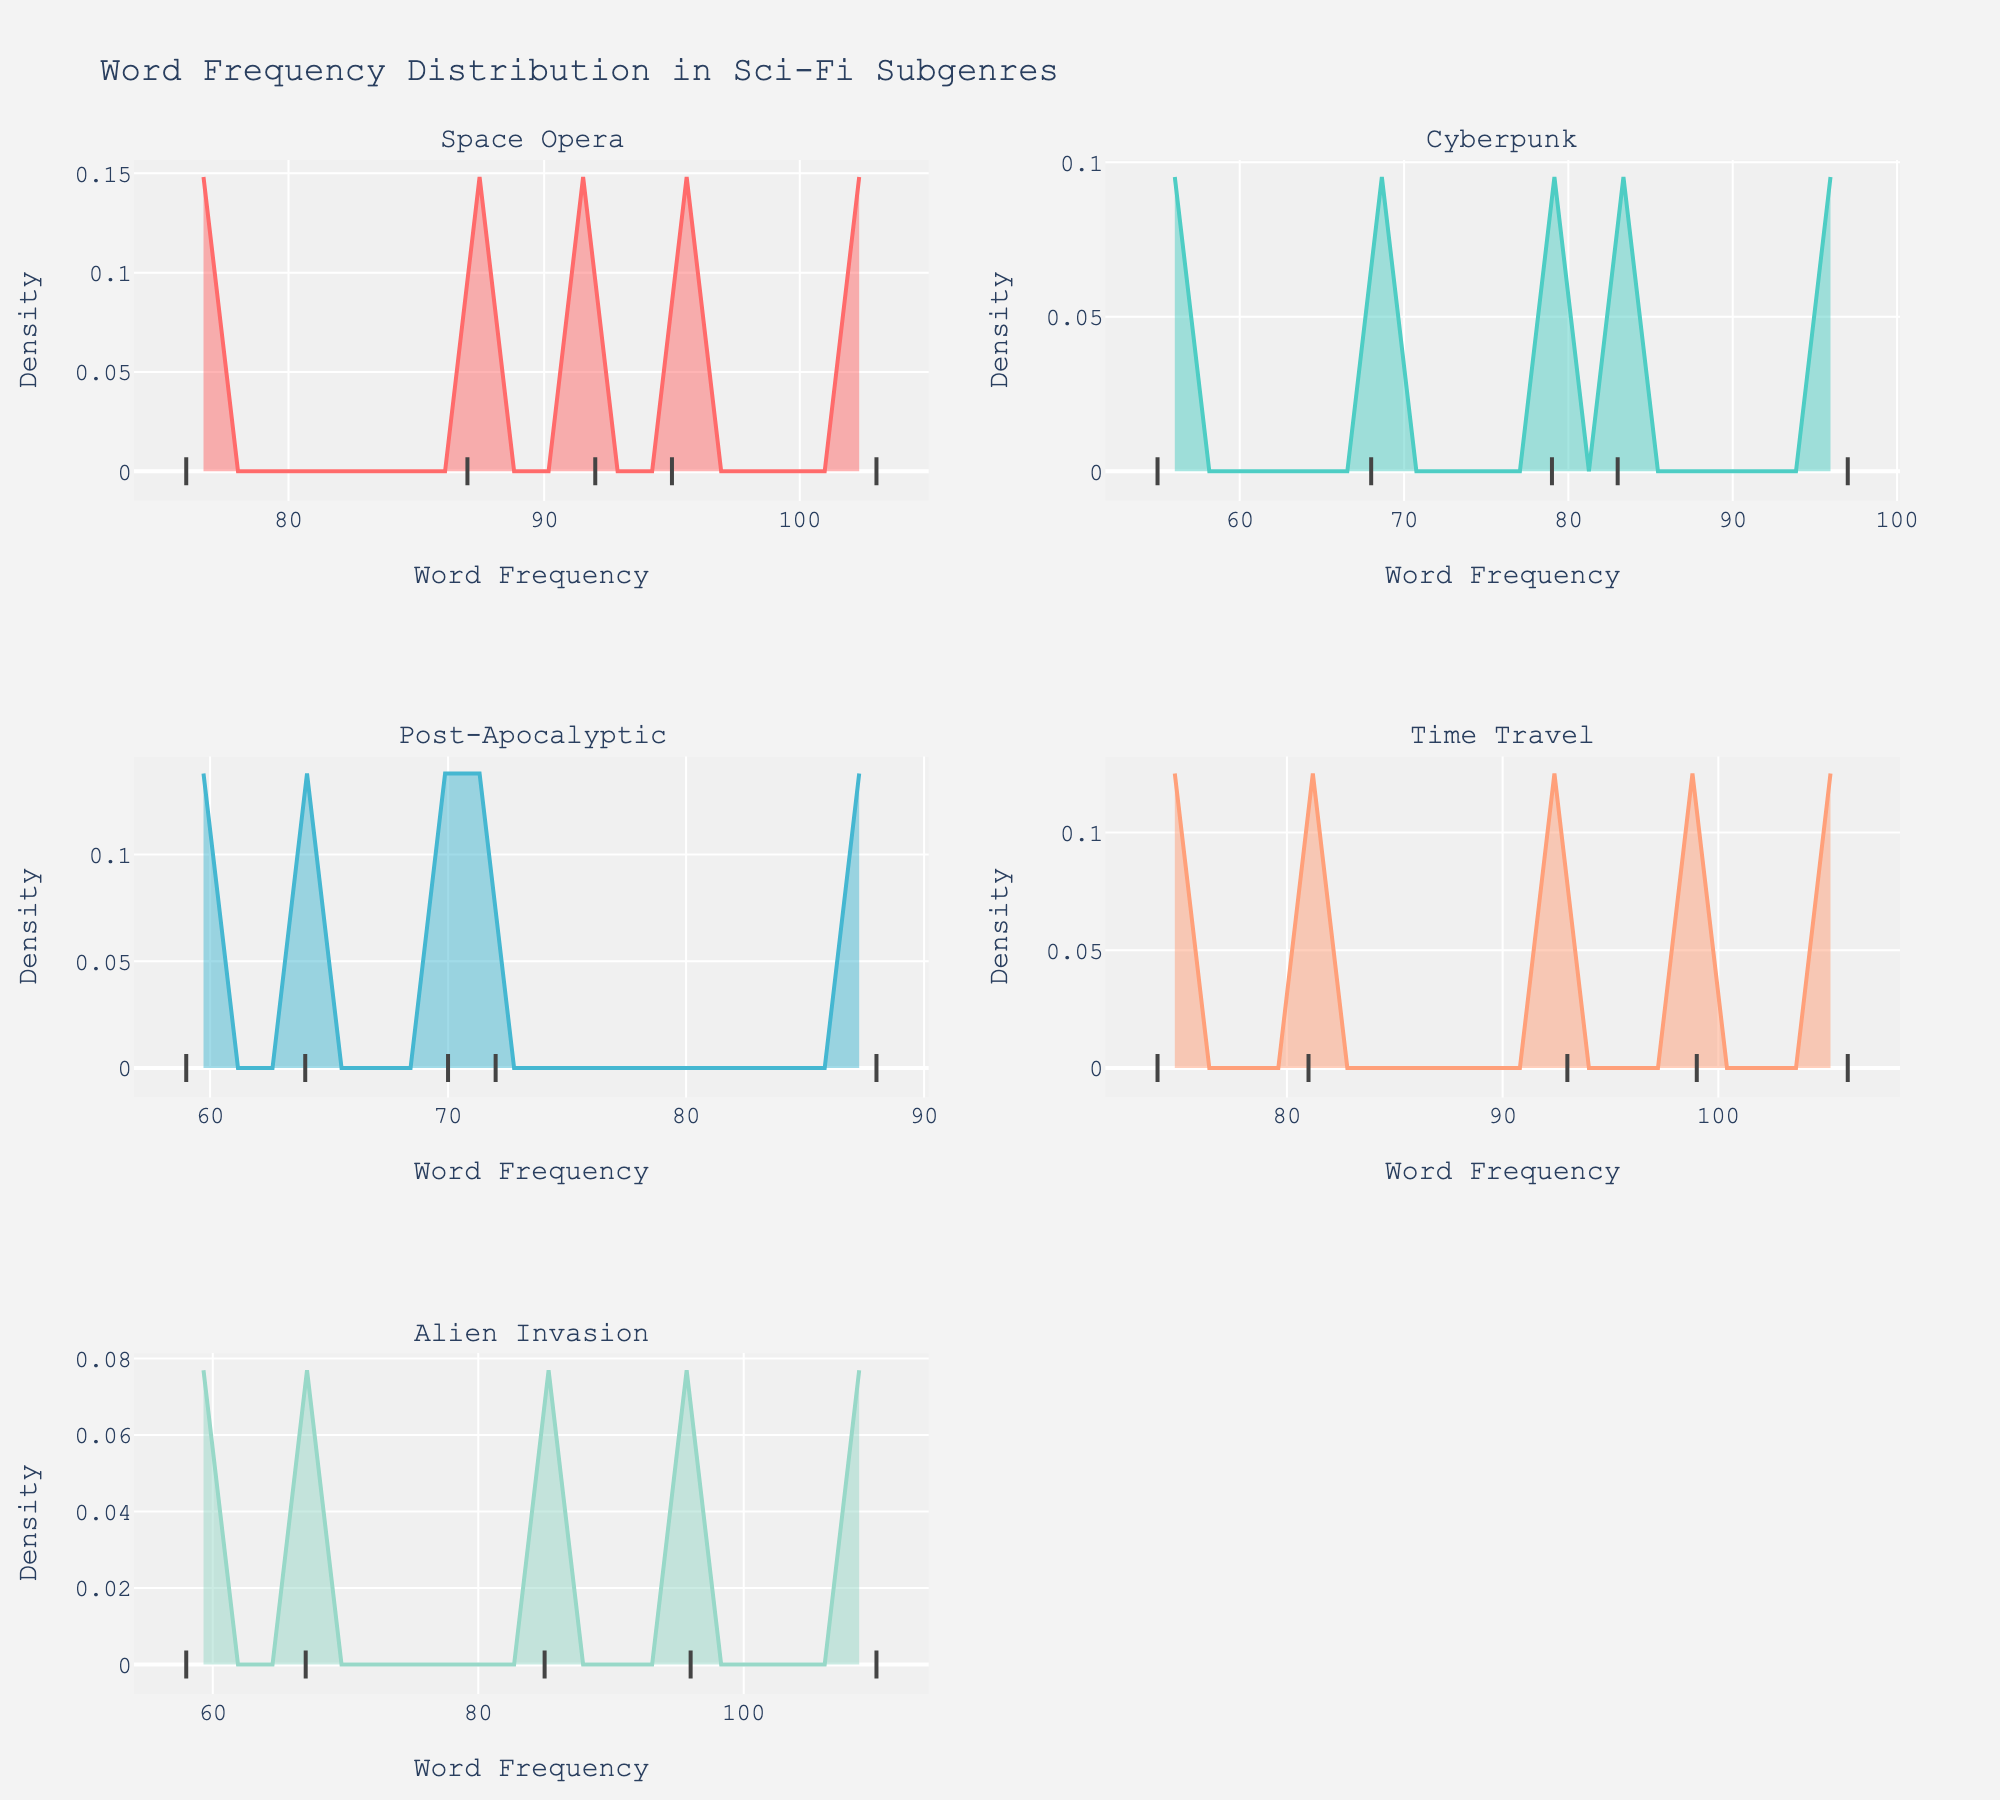Which subgenre has the word with the highest frequency? By looking at the highest peak on the x-axis in each subplot, you can determine the word with the highest frequency. For 'Alien Invasion', the peak reaches around 110 for the word 'invasion', which is the highest among all subgenres.
Answer: Alien Invasion Which subgenre shows the least variability in word frequency? Variability can be inferred from how spread out the points are along the x-axis. 'Cyberpunk' has points that are less spread out compared to other subgenres, suggesting lower variability in word frequencies.
Answer: Cyberpunk How many subgenres exhibit a bimodal distribution? A bimodal distribution is indicated by two distinct peaks in the density plot. By examining each subplot, only 'Time Travel' shows a clear bimodal pattern.
Answer: 1 Which word in the Post-Apocalyptic subgenre has the lowest frequency? In the Post-Apocalyptic subplot, the word 'scavenge' is positioned the furthest to the left on the x-axis, indicating the lowest frequency.
Answer: scavenge What is the frequency of the word 'AI' in the Cyberpunk subgenre? Refer to the specific marker for 'AI' in the Cyberpunk subplot, marked at approximately 97 on the x-axis.
Answer: 97 Is the peak of word frequency density higher in 'Time Travel' or 'Space Opera'? Compare the maximum y-values (height of peaks) of the density plots. The peak in 'Space Opera' is higher than in 'Time Travel'.
Answer: Space Opera What is the average frequency of words in the 'Space Opera' subgenre? Sum the frequencies of the words in 'Space Opera' (87 + 103 + 95 + 76 + 92) and divide by the number of words (5), resulting in (453 / 5).
Answer: 90.6 Among 'Cyberpunk' and 'Alien Invasion', which subgenre has the word with the second-highest frequency? Find the second-highest peaks in the density plots for both subgenres. 'Cyberpunk' has 'AI' at 97, and 'Alien Invasion' has 'humanity' at 96. Thus, 'Cyberpunk' has the higher second peak.
Answer: Cyberpunk What is the difference between the highest and lowest word frequencies in the 'Post-Apocalyptic' subgenre? Identify the highest (88 for 'survivor') and lowest (59 for 'scavenge') frequencies in the 'Post-Apocalyptic' subplot and calculate their difference (88 - 59).
Answer: 29 